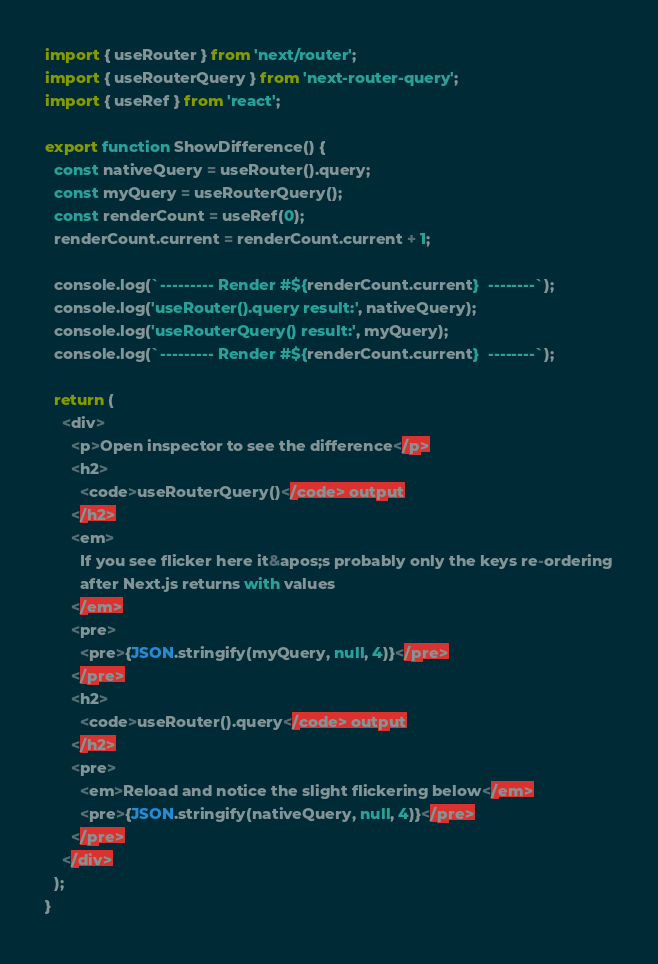<code> <loc_0><loc_0><loc_500><loc_500><_TypeScript_>import { useRouter } from 'next/router';
import { useRouterQuery } from 'next-router-query';
import { useRef } from 'react';

export function ShowDifference() {
  const nativeQuery = useRouter().query;
  const myQuery = useRouterQuery();
  const renderCount = useRef(0);
  renderCount.current = renderCount.current + 1;

  console.log(`--------- Render #${renderCount.current}  --------`);
  console.log('useRouter().query result:', nativeQuery);
  console.log('useRouterQuery() result:', myQuery);
  console.log(`--------- Render #${renderCount.current}  --------`);

  return (
    <div>
      <p>Open inspector to see the difference</p>
      <h2>
        <code>useRouterQuery()</code> output
      </h2>
      <em>
        If you see flicker here it&apos;s probably only the keys re-ordering
        after Next.js returns with values
      </em>
      <pre>
        <pre>{JSON.stringify(myQuery, null, 4)}</pre>
      </pre>
      <h2>
        <code>useRouter().query</code> output
      </h2>
      <pre>
        <em>Reload and notice the slight flickering below</em>
        <pre>{JSON.stringify(nativeQuery, null, 4)}</pre>
      </pre>
    </div>
  );
}
</code> 